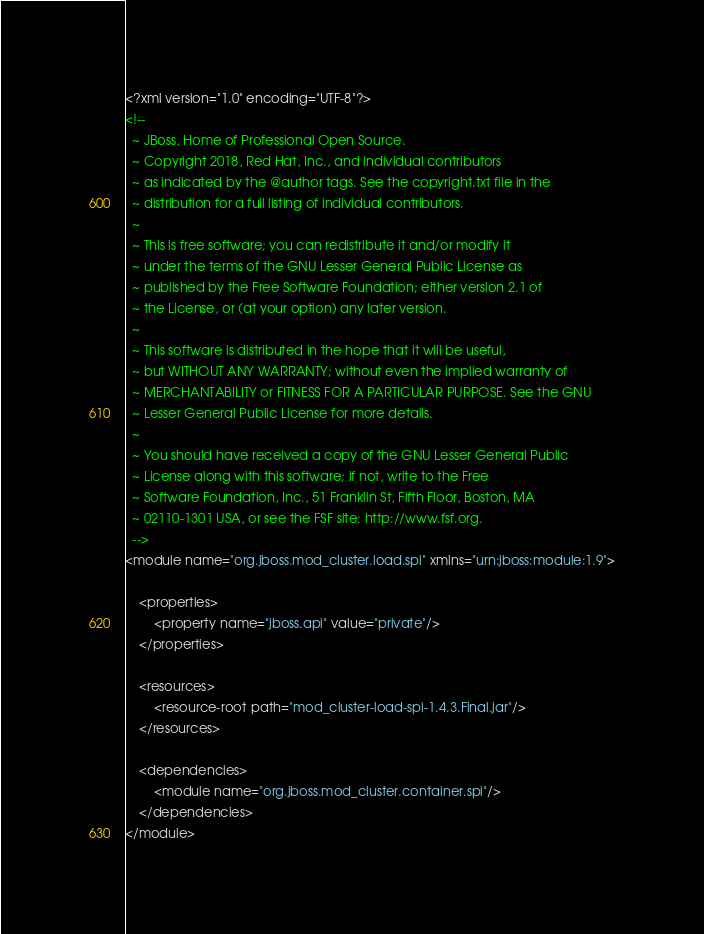Convert code to text. <code><loc_0><loc_0><loc_500><loc_500><_XML_><?xml version="1.0" encoding="UTF-8"?>
<!--
  ~ JBoss, Home of Professional Open Source.
  ~ Copyright 2018, Red Hat, Inc., and individual contributors
  ~ as indicated by the @author tags. See the copyright.txt file in the
  ~ distribution for a full listing of individual contributors.
  ~
  ~ This is free software; you can redistribute it and/or modify it
  ~ under the terms of the GNU Lesser General Public License as
  ~ published by the Free Software Foundation; either version 2.1 of
  ~ the License, or (at your option) any later version.
  ~
  ~ This software is distributed in the hope that it will be useful,
  ~ but WITHOUT ANY WARRANTY; without even the implied warranty of
  ~ MERCHANTABILITY or FITNESS FOR A PARTICULAR PURPOSE. See the GNU
  ~ Lesser General Public License for more details.
  ~
  ~ You should have received a copy of the GNU Lesser General Public
  ~ License along with this software; if not, write to the Free
  ~ Software Foundation, Inc., 51 Franklin St, Fifth Floor, Boston, MA
  ~ 02110-1301 USA, or see the FSF site: http://www.fsf.org.
  -->
<module name="org.jboss.mod_cluster.load.spi" xmlns="urn:jboss:module:1.9">

    <properties>
        <property name="jboss.api" value="private"/>
    </properties>

    <resources>
        <resource-root path="mod_cluster-load-spi-1.4.3.Final.jar"/>
    </resources>

    <dependencies>
        <module name="org.jboss.mod_cluster.container.spi"/>
    </dependencies>
</module>
</code> 